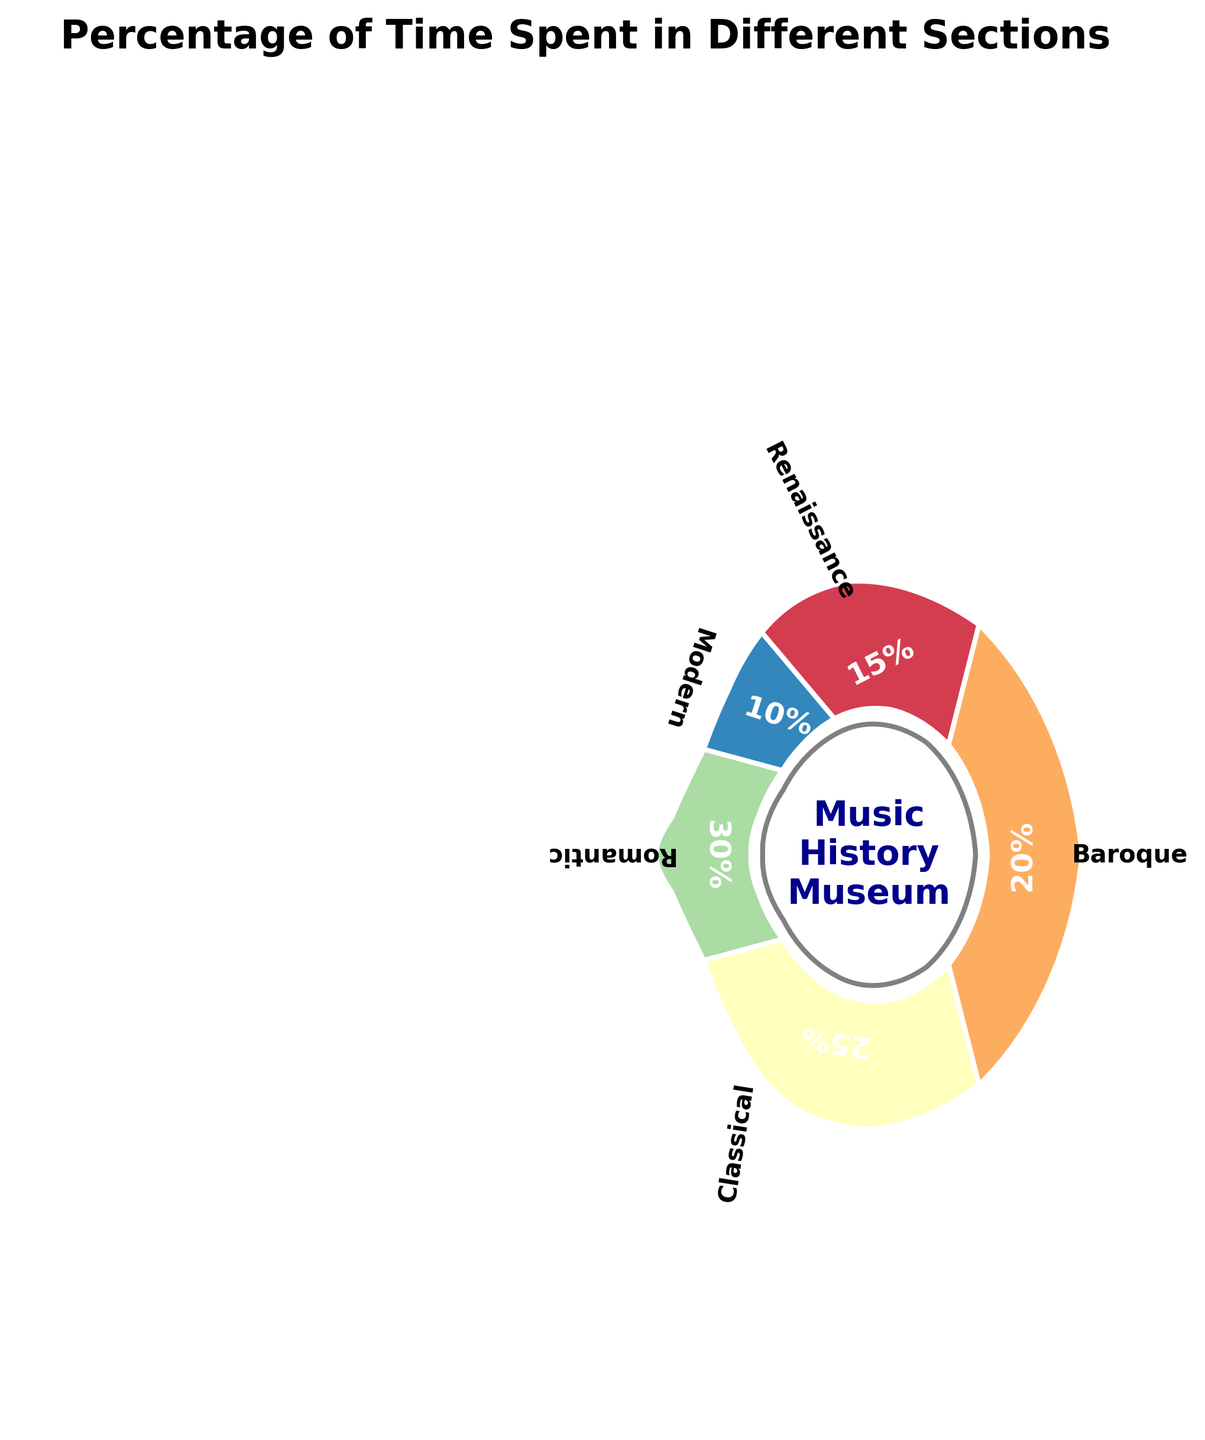What is the title of the figure? The title is usually positioned at the top of the figure and helps to summarize what the figure is about. Observing the top of the figure, the title reads "Percentage of Time Spent in Different Sections".
Answer: Percentage of Time Spent in Different Sections How much percentage of time is spent in the Classical era section? Labels indicating percentages are shown on the corresponding sections. Observing the section labeled 'Classical', the percentage is marked as 25%.
Answer: 25% Which era has the smallest percentage of time spent in it? To find the era with the smallest percentage, compare all the percentages displayed in each section. The 'Modern' era has the smallest percentage, marked as 10%.
Answer: Modern What is the total percentage of time spent in the Renaissance and Baroque eras combined? To find the total, simply add the percentages of the Renaissance (15%) and Baroque (20%) eras, which gives 15% + 20% = 35%.
Answer: 35% Which two eras have a combined percentage of 45%? We need to find which two percentages sum up to 45%. The Classical (25%) and Modern (10%) add up to 35%, and the Renaissance (15%) and Romantic (30%) also combine for 45%. Therefore, the correct pair is Renaissance (15%) and Romantic (30%).
Answer: Renaissance and Romantic Compare the time spent in the Baroque and Romantic eras. Which one has more, and by how much? Observe the percentages for the Baroque (20%) and Romantic (30%) eras. The Romantic era has more time spent, specifically 30% - 20% = 10% more.
Answer: Romantic by 10% What is the average percentage of time spent across all eras? To find the average percentage, add all percentages and then divide by the number of eras. (15% + 20% + 25% + 30% + 10%) / 5 = 20%.
Answer: 20% What is the percentage difference between the era with the highest and the lowest time spent? Identify the highest (Romantic, 30%) and the lowest (Modern, 10%) percentages. The difference is 30% - 10% = 20%.
Answer: 20% How are the sections distinguished on the plot? The sections are distinguished by different colors and labeled with associated percentages and eras. Each section is a wedge with distinct color, separated by white edges.
Answer: By different colors and labels Is the time spent in the Romantic era more than the combined time spent in the Renaissance and Modern eras? Calculate the combined time of the Renaissance (15%) and Modern (10%) eras, which is 15% + 10% = 25%. The Romantic era alone is 30%, which is indeed more than 25%.
Answer: Yes 